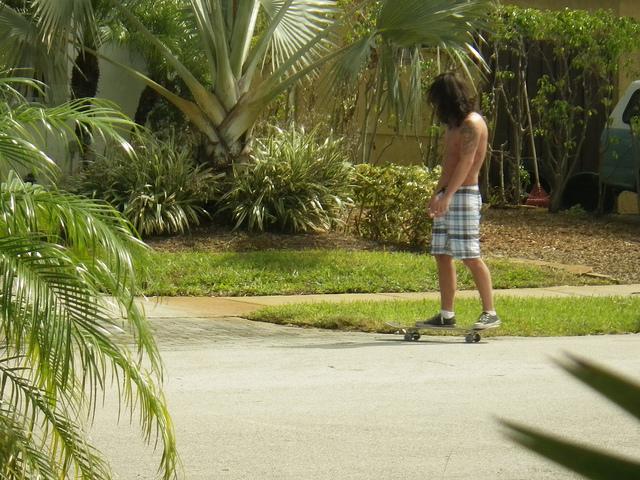Is he wearing a shirt?
Be succinct. No. Where was the picture taken of the skateboarder?
Answer briefly. Driveway. Is the guy going for a walk?
Quick response, please. No. What is the man doing?
Short answer required. Skateboarding. 